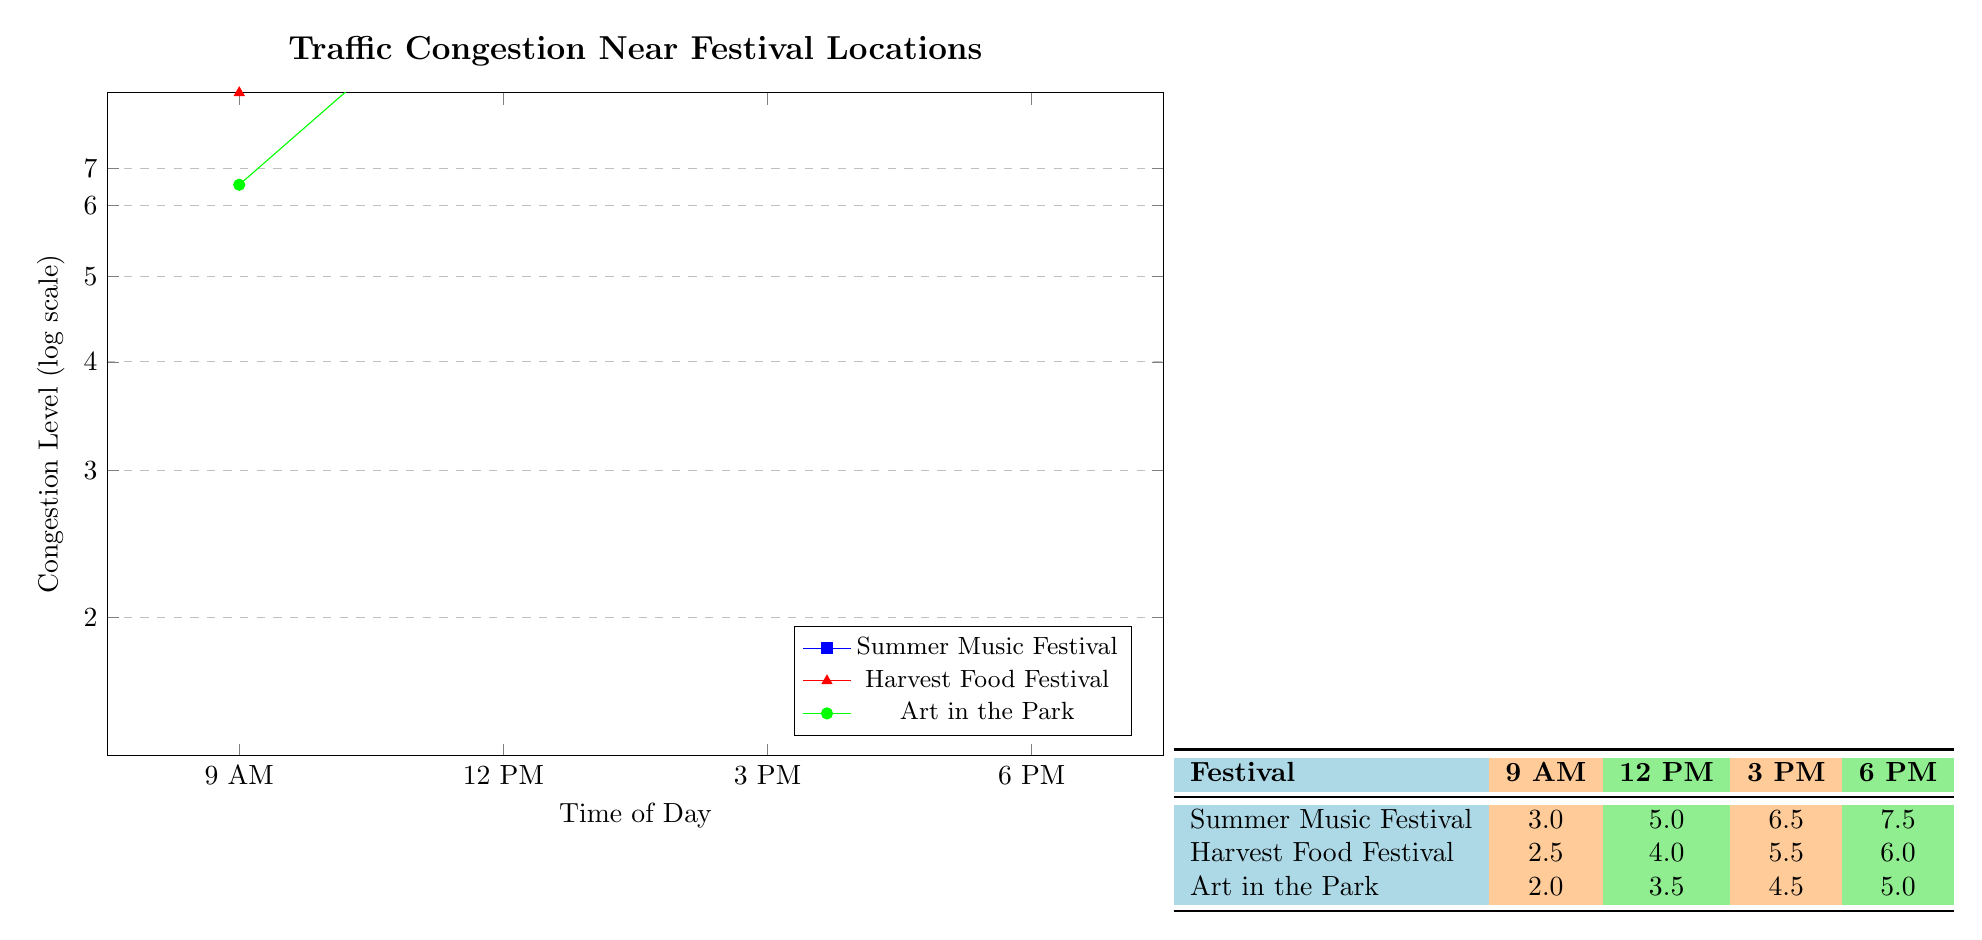What is the congestion level for the Summer Music Festival at 12 PM? The table shows the congestion level for the Summer Music Festival at 12 PM as 5.0.
Answer: 5.0 What is the highest congestion level recorded during the Harvest Food Festival? Looking across the rows for the Harvest Food Festival, the highest congestion level is at 6 PM, which is 6.0.
Answer: 6.0 What is the average congestion level for Art in the Park during the festival times? We add the congestion levels for Art in the Park at all times: (2.0 + 3.5 + 4.5 + 5.0) = 15.0. There are 4 data points, so we divide 15.0 by 4 to get the average: 15.0 / 4 = 3.75.
Answer: 3.75 Is the congestion level at 3 PM for any festival higher than 5.5? Checking the 3 PM congestion levels, Summer Music Festival has 6.5, which is higher than 5.5, so the statement is true.
Answer: Yes What is the total congestion level for all festivals at 9 AM? At 9 AM, the Summer Music Festival has 3.0, Harvest Food Festival has 2.5, and Art in the Park has 2.0. We add these levels together: 3.0 + 2.5 + 2.0 = 7.5.
Answer: 7.5 Which festival has the highest congestion level at 6 PM? The 6 PM congestion levels show Summer Music Festival at 7.5, Harvest Food Festival at 6.0, and Art in the Park at 5.0. The highest is 7.5, from the Summer Music Festival.
Answer: Summer Music Festival Is the congestion level for Art in the Park at 3 PM lower than the level for Harvest Food Festival at the same time? At 3 PM, Art in the Park has 4.5 while Harvest Food Festival has 5.5. The level for Art in the Park is lower, so the statement is true.
Answer: Yes What are the congestion levels at 12 PM for East Coast festivals? The congestion levels at 12 PM are: Summer Music Festival 5.0, Harvest Food Festival 4.0, and Art in the Park 3.5. No festivals are mentioned as East Coast, but we assume they might be. We can report those values.
Answer: 5.0, 4.0, 3.5 